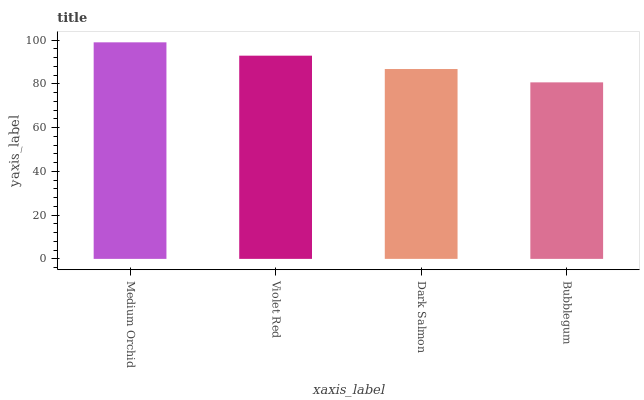Is Bubblegum the minimum?
Answer yes or no. Yes. Is Medium Orchid the maximum?
Answer yes or no. Yes. Is Violet Red the minimum?
Answer yes or no. No. Is Violet Red the maximum?
Answer yes or no. No. Is Medium Orchid greater than Violet Red?
Answer yes or no. Yes. Is Violet Red less than Medium Orchid?
Answer yes or no. Yes. Is Violet Red greater than Medium Orchid?
Answer yes or no. No. Is Medium Orchid less than Violet Red?
Answer yes or no. No. Is Violet Red the high median?
Answer yes or no. Yes. Is Dark Salmon the low median?
Answer yes or no. Yes. Is Bubblegum the high median?
Answer yes or no. No. Is Medium Orchid the low median?
Answer yes or no. No. 